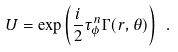Convert formula to latex. <formula><loc_0><loc_0><loc_500><loc_500>U = \exp \left ( { \frac { i } { 2 } \tau ^ { n } _ { \phi } \Gamma ( r , \theta ) } \right ) \ .</formula> 